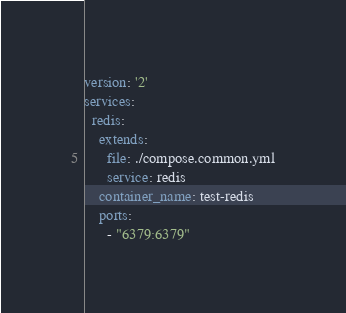<code> <loc_0><loc_0><loc_500><loc_500><_YAML_>version: '2'
services:
  redis:
    extends:
      file: ./compose.common.yml
      service: redis
    container_name: test-redis
    ports:
      - "6379:6379"



</code> 